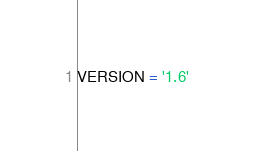<code> <loc_0><loc_0><loc_500><loc_500><_Python_>VERSION = '1.6'
</code> 